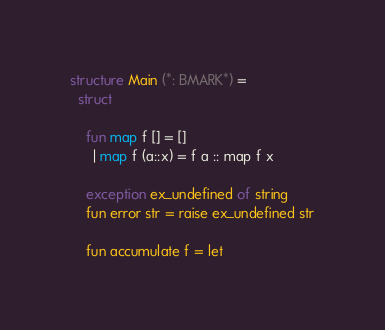Convert code to text. <code><loc_0><loc_0><loc_500><loc_500><_SML_>structure Main (*: BMARK*) = 
  struct

    fun map f [] = []
      | map f (a::x) = f a :: map f x

    exception ex_undefined of string
    fun error str = raise ex_undefined str

    fun accumulate f = let</code> 